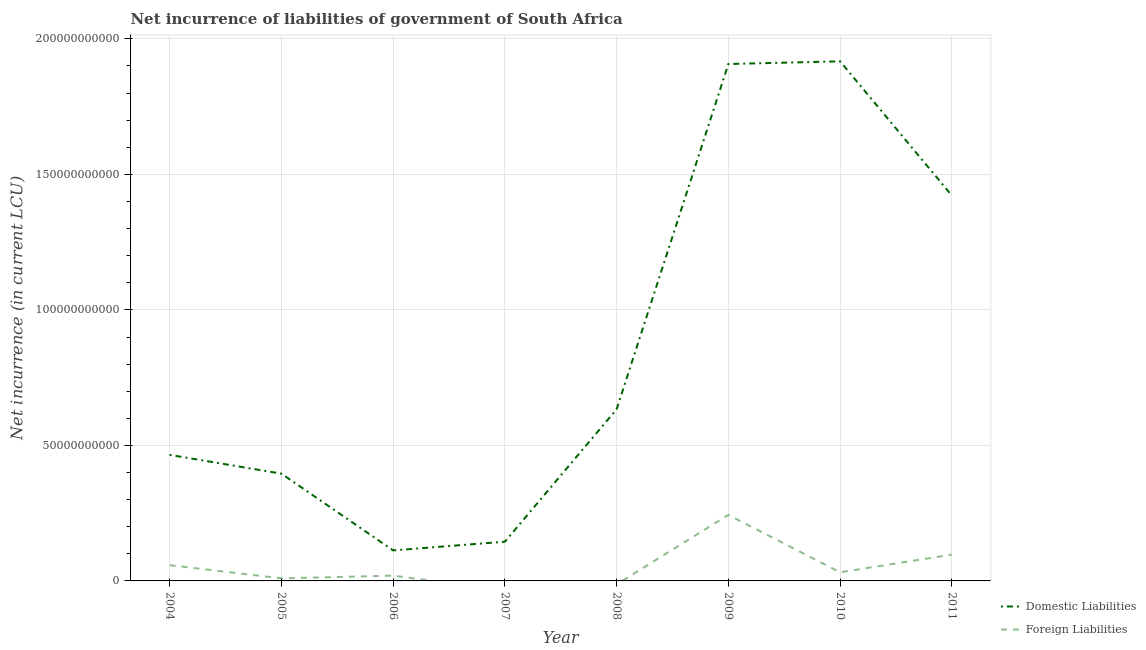How many different coloured lines are there?
Offer a terse response. 2. Is the number of lines equal to the number of legend labels?
Provide a succinct answer. No. What is the net incurrence of domestic liabilities in 2009?
Keep it short and to the point. 1.91e+11. Across all years, what is the maximum net incurrence of foreign liabilities?
Your answer should be very brief. 2.44e+1. What is the total net incurrence of domestic liabilities in the graph?
Offer a terse response. 7.00e+11. What is the difference between the net incurrence of domestic liabilities in 2004 and that in 2010?
Give a very brief answer. -1.45e+11. What is the difference between the net incurrence of foreign liabilities in 2006 and the net incurrence of domestic liabilities in 2008?
Your answer should be compact. -6.14e+1. What is the average net incurrence of domestic liabilities per year?
Give a very brief answer. 8.75e+1. In the year 2010, what is the difference between the net incurrence of foreign liabilities and net incurrence of domestic liabilities?
Your response must be concise. -1.89e+11. What is the ratio of the net incurrence of foreign liabilities in 2006 to that in 2010?
Ensure brevity in your answer.  0.61. Is the difference between the net incurrence of foreign liabilities in 2006 and 2010 greater than the difference between the net incurrence of domestic liabilities in 2006 and 2010?
Your answer should be very brief. Yes. What is the difference between the highest and the second highest net incurrence of foreign liabilities?
Provide a succinct answer. 1.46e+1. What is the difference between the highest and the lowest net incurrence of foreign liabilities?
Your answer should be compact. 2.44e+1. Is the sum of the net incurrence of foreign liabilities in 2010 and 2011 greater than the maximum net incurrence of domestic liabilities across all years?
Provide a short and direct response. No. How many years are there in the graph?
Make the answer very short. 8. Are the values on the major ticks of Y-axis written in scientific E-notation?
Provide a short and direct response. No. Does the graph contain any zero values?
Offer a terse response. Yes. What is the title of the graph?
Offer a terse response. Net incurrence of liabilities of government of South Africa. What is the label or title of the Y-axis?
Ensure brevity in your answer.  Net incurrence (in current LCU). What is the Net incurrence (in current LCU) of Domestic Liabilities in 2004?
Your answer should be compact. 4.65e+1. What is the Net incurrence (in current LCU) in Foreign Liabilities in 2004?
Give a very brief answer. 5.81e+09. What is the Net incurrence (in current LCU) in Domestic Liabilities in 2005?
Offer a very short reply. 3.96e+1. What is the Net incurrence (in current LCU) of Foreign Liabilities in 2005?
Provide a short and direct response. 9.50e+08. What is the Net incurrence (in current LCU) of Domestic Liabilities in 2006?
Offer a terse response. 1.13e+1. What is the Net incurrence (in current LCU) of Foreign Liabilities in 2006?
Your answer should be very brief. 1.94e+09. What is the Net incurrence (in current LCU) in Domestic Liabilities in 2007?
Offer a very short reply. 1.45e+1. What is the Net incurrence (in current LCU) in Domestic Liabilities in 2008?
Offer a very short reply. 6.33e+1. What is the Net incurrence (in current LCU) of Foreign Liabilities in 2008?
Provide a succinct answer. 0. What is the Net incurrence (in current LCU) of Domestic Liabilities in 2009?
Provide a short and direct response. 1.91e+11. What is the Net incurrence (in current LCU) of Foreign Liabilities in 2009?
Make the answer very short. 2.44e+1. What is the Net incurrence (in current LCU) of Domestic Liabilities in 2010?
Provide a short and direct response. 1.92e+11. What is the Net incurrence (in current LCU) in Foreign Liabilities in 2010?
Give a very brief answer. 3.18e+09. What is the Net incurrence (in current LCU) in Domestic Liabilities in 2011?
Provide a succinct answer. 1.42e+11. What is the Net incurrence (in current LCU) of Foreign Liabilities in 2011?
Provide a short and direct response. 9.71e+09. Across all years, what is the maximum Net incurrence (in current LCU) of Domestic Liabilities?
Offer a very short reply. 1.92e+11. Across all years, what is the maximum Net incurrence (in current LCU) in Foreign Liabilities?
Offer a very short reply. 2.44e+1. Across all years, what is the minimum Net incurrence (in current LCU) in Domestic Liabilities?
Ensure brevity in your answer.  1.13e+1. What is the total Net incurrence (in current LCU) in Domestic Liabilities in the graph?
Offer a terse response. 7.00e+11. What is the total Net incurrence (in current LCU) of Foreign Liabilities in the graph?
Provide a succinct answer. 4.59e+1. What is the difference between the Net incurrence (in current LCU) in Domestic Liabilities in 2004 and that in 2005?
Your answer should be compact. 6.92e+09. What is the difference between the Net incurrence (in current LCU) of Foreign Liabilities in 2004 and that in 2005?
Keep it short and to the point. 4.86e+09. What is the difference between the Net incurrence (in current LCU) in Domestic Liabilities in 2004 and that in 2006?
Give a very brief answer. 3.52e+1. What is the difference between the Net incurrence (in current LCU) of Foreign Liabilities in 2004 and that in 2006?
Give a very brief answer. 3.87e+09. What is the difference between the Net incurrence (in current LCU) of Domestic Liabilities in 2004 and that in 2007?
Offer a terse response. 3.20e+1. What is the difference between the Net incurrence (in current LCU) in Domestic Liabilities in 2004 and that in 2008?
Your response must be concise. -1.68e+1. What is the difference between the Net incurrence (in current LCU) in Domestic Liabilities in 2004 and that in 2009?
Keep it short and to the point. -1.44e+11. What is the difference between the Net incurrence (in current LCU) in Foreign Liabilities in 2004 and that in 2009?
Keep it short and to the point. -1.85e+1. What is the difference between the Net incurrence (in current LCU) of Domestic Liabilities in 2004 and that in 2010?
Offer a very short reply. -1.45e+11. What is the difference between the Net incurrence (in current LCU) of Foreign Liabilities in 2004 and that in 2010?
Make the answer very short. 2.63e+09. What is the difference between the Net incurrence (in current LCU) in Domestic Liabilities in 2004 and that in 2011?
Your answer should be compact. -9.57e+1. What is the difference between the Net incurrence (in current LCU) in Foreign Liabilities in 2004 and that in 2011?
Make the answer very short. -3.90e+09. What is the difference between the Net incurrence (in current LCU) in Domestic Liabilities in 2005 and that in 2006?
Your answer should be very brief. 2.83e+1. What is the difference between the Net incurrence (in current LCU) in Foreign Liabilities in 2005 and that in 2006?
Your answer should be compact. -9.93e+08. What is the difference between the Net incurrence (in current LCU) in Domestic Liabilities in 2005 and that in 2007?
Provide a succinct answer. 2.51e+1. What is the difference between the Net incurrence (in current LCU) in Domestic Liabilities in 2005 and that in 2008?
Your answer should be compact. -2.37e+1. What is the difference between the Net incurrence (in current LCU) in Domestic Liabilities in 2005 and that in 2009?
Keep it short and to the point. -1.51e+11. What is the difference between the Net incurrence (in current LCU) in Foreign Liabilities in 2005 and that in 2009?
Provide a succinct answer. -2.34e+1. What is the difference between the Net incurrence (in current LCU) in Domestic Liabilities in 2005 and that in 2010?
Give a very brief answer. -1.52e+11. What is the difference between the Net incurrence (in current LCU) of Foreign Liabilities in 2005 and that in 2010?
Make the answer very short. -2.23e+09. What is the difference between the Net incurrence (in current LCU) of Domestic Liabilities in 2005 and that in 2011?
Offer a very short reply. -1.03e+11. What is the difference between the Net incurrence (in current LCU) in Foreign Liabilities in 2005 and that in 2011?
Your response must be concise. -8.76e+09. What is the difference between the Net incurrence (in current LCU) of Domestic Liabilities in 2006 and that in 2007?
Your answer should be very brief. -3.21e+09. What is the difference between the Net incurrence (in current LCU) in Domestic Liabilities in 2006 and that in 2008?
Give a very brief answer. -5.21e+1. What is the difference between the Net incurrence (in current LCU) of Domestic Liabilities in 2006 and that in 2009?
Your response must be concise. -1.79e+11. What is the difference between the Net incurrence (in current LCU) in Foreign Liabilities in 2006 and that in 2009?
Give a very brief answer. -2.24e+1. What is the difference between the Net incurrence (in current LCU) in Domestic Liabilities in 2006 and that in 2010?
Your response must be concise. -1.80e+11. What is the difference between the Net incurrence (in current LCU) of Foreign Liabilities in 2006 and that in 2010?
Your answer should be very brief. -1.24e+09. What is the difference between the Net incurrence (in current LCU) of Domestic Liabilities in 2006 and that in 2011?
Ensure brevity in your answer.  -1.31e+11. What is the difference between the Net incurrence (in current LCU) of Foreign Liabilities in 2006 and that in 2011?
Provide a short and direct response. -7.77e+09. What is the difference between the Net incurrence (in current LCU) in Domestic Liabilities in 2007 and that in 2008?
Make the answer very short. -4.89e+1. What is the difference between the Net incurrence (in current LCU) in Domestic Liabilities in 2007 and that in 2009?
Offer a very short reply. -1.76e+11. What is the difference between the Net incurrence (in current LCU) in Domestic Liabilities in 2007 and that in 2010?
Provide a short and direct response. -1.77e+11. What is the difference between the Net incurrence (in current LCU) in Domestic Liabilities in 2007 and that in 2011?
Offer a terse response. -1.28e+11. What is the difference between the Net incurrence (in current LCU) in Domestic Liabilities in 2008 and that in 2009?
Your answer should be compact. -1.27e+11. What is the difference between the Net incurrence (in current LCU) in Domestic Liabilities in 2008 and that in 2010?
Your response must be concise. -1.28e+11. What is the difference between the Net incurrence (in current LCU) of Domestic Liabilities in 2008 and that in 2011?
Your response must be concise. -7.89e+1. What is the difference between the Net incurrence (in current LCU) in Domestic Liabilities in 2009 and that in 2010?
Offer a very short reply. -9.92e+08. What is the difference between the Net incurrence (in current LCU) in Foreign Liabilities in 2009 and that in 2010?
Offer a very short reply. 2.12e+1. What is the difference between the Net incurrence (in current LCU) of Domestic Liabilities in 2009 and that in 2011?
Give a very brief answer. 4.85e+1. What is the difference between the Net incurrence (in current LCU) in Foreign Liabilities in 2009 and that in 2011?
Your answer should be compact. 1.46e+1. What is the difference between the Net incurrence (in current LCU) of Domestic Liabilities in 2010 and that in 2011?
Your response must be concise. 4.95e+1. What is the difference between the Net incurrence (in current LCU) of Foreign Liabilities in 2010 and that in 2011?
Your answer should be compact. -6.53e+09. What is the difference between the Net incurrence (in current LCU) of Domestic Liabilities in 2004 and the Net incurrence (in current LCU) of Foreign Liabilities in 2005?
Ensure brevity in your answer.  4.56e+1. What is the difference between the Net incurrence (in current LCU) in Domestic Liabilities in 2004 and the Net incurrence (in current LCU) in Foreign Liabilities in 2006?
Give a very brief answer. 4.46e+1. What is the difference between the Net incurrence (in current LCU) in Domestic Liabilities in 2004 and the Net incurrence (in current LCU) in Foreign Liabilities in 2009?
Ensure brevity in your answer.  2.22e+1. What is the difference between the Net incurrence (in current LCU) of Domestic Liabilities in 2004 and the Net incurrence (in current LCU) of Foreign Liabilities in 2010?
Provide a succinct answer. 4.33e+1. What is the difference between the Net incurrence (in current LCU) in Domestic Liabilities in 2004 and the Net incurrence (in current LCU) in Foreign Liabilities in 2011?
Give a very brief answer. 3.68e+1. What is the difference between the Net incurrence (in current LCU) of Domestic Liabilities in 2005 and the Net incurrence (in current LCU) of Foreign Liabilities in 2006?
Ensure brevity in your answer.  3.76e+1. What is the difference between the Net incurrence (in current LCU) in Domestic Liabilities in 2005 and the Net incurrence (in current LCU) in Foreign Liabilities in 2009?
Provide a succinct answer. 1.52e+1. What is the difference between the Net incurrence (in current LCU) in Domestic Liabilities in 2005 and the Net incurrence (in current LCU) in Foreign Liabilities in 2010?
Your answer should be compact. 3.64e+1. What is the difference between the Net incurrence (in current LCU) of Domestic Liabilities in 2005 and the Net incurrence (in current LCU) of Foreign Liabilities in 2011?
Your answer should be compact. 2.99e+1. What is the difference between the Net incurrence (in current LCU) of Domestic Liabilities in 2006 and the Net incurrence (in current LCU) of Foreign Liabilities in 2009?
Offer a terse response. -1.31e+1. What is the difference between the Net incurrence (in current LCU) of Domestic Liabilities in 2006 and the Net incurrence (in current LCU) of Foreign Liabilities in 2010?
Provide a short and direct response. 8.08e+09. What is the difference between the Net incurrence (in current LCU) of Domestic Liabilities in 2006 and the Net incurrence (in current LCU) of Foreign Liabilities in 2011?
Provide a succinct answer. 1.55e+09. What is the difference between the Net incurrence (in current LCU) of Domestic Liabilities in 2007 and the Net incurrence (in current LCU) of Foreign Liabilities in 2009?
Provide a succinct answer. -9.88e+09. What is the difference between the Net incurrence (in current LCU) in Domestic Liabilities in 2007 and the Net incurrence (in current LCU) in Foreign Liabilities in 2010?
Provide a succinct answer. 1.13e+1. What is the difference between the Net incurrence (in current LCU) in Domestic Liabilities in 2007 and the Net incurrence (in current LCU) in Foreign Liabilities in 2011?
Keep it short and to the point. 4.76e+09. What is the difference between the Net incurrence (in current LCU) of Domestic Liabilities in 2008 and the Net incurrence (in current LCU) of Foreign Liabilities in 2009?
Your answer should be compact. 3.90e+1. What is the difference between the Net incurrence (in current LCU) in Domestic Liabilities in 2008 and the Net incurrence (in current LCU) in Foreign Liabilities in 2010?
Your answer should be compact. 6.01e+1. What is the difference between the Net incurrence (in current LCU) in Domestic Liabilities in 2008 and the Net incurrence (in current LCU) in Foreign Liabilities in 2011?
Make the answer very short. 5.36e+1. What is the difference between the Net incurrence (in current LCU) in Domestic Liabilities in 2009 and the Net incurrence (in current LCU) in Foreign Liabilities in 2010?
Ensure brevity in your answer.  1.88e+11. What is the difference between the Net incurrence (in current LCU) in Domestic Liabilities in 2009 and the Net incurrence (in current LCU) in Foreign Liabilities in 2011?
Offer a terse response. 1.81e+11. What is the difference between the Net incurrence (in current LCU) of Domestic Liabilities in 2010 and the Net incurrence (in current LCU) of Foreign Liabilities in 2011?
Keep it short and to the point. 1.82e+11. What is the average Net incurrence (in current LCU) in Domestic Liabilities per year?
Offer a very short reply. 8.75e+1. What is the average Net incurrence (in current LCU) of Foreign Liabilities per year?
Make the answer very short. 5.74e+09. In the year 2004, what is the difference between the Net incurrence (in current LCU) in Domestic Liabilities and Net incurrence (in current LCU) in Foreign Liabilities?
Ensure brevity in your answer.  4.07e+1. In the year 2005, what is the difference between the Net incurrence (in current LCU) of Domestic Liabilities and Net incurrence (in current LCU) of Foreign Liabilities?
Provide a succinct answer. 3.86e+1. In the year 2006, what is the difference between the Net incurrence (in current LCU) in Domestic Liabilities and Net incurrence (in current LCU) in Foreign Liabilities?
Provide a succinct answer. 9.32e+09. In the year 2009, what is the difference between the Net incurrence (in current LCU) in Domestic Liabilities and Net incurrence (in current LCU) in Foreign Liabilities?
Your answer should be very brief. 1.66e+11. In the year 2010, what is the difference between the Net incurrence (in current LCU) in Domestic Liabilities and Net incurrence (in current LCU) in Foreign Liabilities?
Keep it short and to the point. 1.89e+11. In the year 2011, what is the difference between the Net incurrence (in current LCU) in Domestic Liabilities and Net incurrence (in current LCU) in Foreign Liabilities?
Offer a terse response. 1.32e+11. What is the ratio of the Net incurrence (in current LCU) in Domestic Liabilities in 2004 to that in 2005?
Your response must be concise. 1.17. What is the ratio of the Net incurrence (in current LCU) of Foreign Liabilities in 2004 to that in 2005?
Provide a succinct answer. 6.11. What is the ratio of the Net incurrence (in current LCU) in Domestic Liabilities in 2004 to that in 2006?
Make the answer very short. 4.13. What is the ratio of the Net incurrence (in current LCU) in Foreign Liabilities in 2004 to that in 2006?
Ensure brevity in your answer.  2.99. What is the ratio of the Net incurrence (in current LCU) of Domestic Liabilities in 2004 to that in 2007?
Provide a succinct answer. 3.21. What is the ratio of the Net incurrence (in current LCU) in Domestic Liabilities in 2004 to that in 2008?
Provide a short and direct response. 0.73. What is the ratio of the Net incurrence (in current LCU) in Domestic Liabilities in 2004 to that in 2009?
Your answer should be very brief. 0.24. What is the ratio of the Net incurrence (in current LCU) of Foreign Liabilities in 2004 to that in 2009?
Make the answer very short. 0.24. What is the ratio of the Net incurrence (in current LCU) of Domestic Liabilities in 2004 to that in 2010?
Ensure brevity in your answer.  0.24. What is the ratio of the Net incurrence (in current LCU) of Foreign Liabilities in 2004 to that in 2010?
Make the answer very short. 1.83. What is the ratio of the Net incurrence (in current LCU) of Domestic Liabilities in 2004 to that in 2011?
Offer a very short reply. 0.33. What is the ratio of the Net incurrence (in current LCU) of Foreign Liabilities in 2004 to that in 2011?
Your response must be concise. 0.6. What is the ratio of the Net incurrence (in current LCU) in Domestic Liabilities in 2005 to that in 2006?
Ensure brevity in your answer.  3.52. What is the ratio of the Net incurrence (in current LCU) in Foreign Liabilities in 2005 to that in 2006?
Your answer should be very brief. 0.49. What is the ratio of the Net incurrence (in current LCU) of Domestic Liabilities in 2005 to that in 2007?
Your answer should be compact. 2.73. What is the ratio of the Net incurrence (in current LCU) of Domestic Liabilities in 2005 to that in 2008?
Offer a terse response. 0.63. What is the ratio of the Net incurrence (in current LCU) in Domestic Liabilities in 2005 to that in 2009?
Provide a short and direct response. 0.21. What is the ratio of the Net incurrence (in current LCU) of Foreign Liabilities in 2005 to that in 2009?
Provide a succinct answer. 0.04. What is the ratio of the Net incurrence (in current LCU) in Domestic Liabilities in 2005 to that in 2010?
Keep it short and to the point. 0.21. What is the ratio of the Net incurrence (in current LCU) of Foreign Liabilities in 2005 to that in 2010?
Offer a terse response. 0.3. What is the ratio of the Net incurrence (in current LCU) of Domestic Liabilities in 2005 to that in 2011?
Give a very brief answer. 0.28. What is the ratio of the Net incurrence (in current LCU) in Foreign Liabilities in 2005 to that in 2011?
Provide a short and direct response. 0.1. What is the ratio of the Net incurrence (in current LCU) of Domestic Liabilities in 2006 to that in 2007?
Keep it short and to the point. 0.78. What is the ratio of the Net incurrence (in current LCU) in Domestic Liabilities in 2006 to that in 2008?
Offer a terse response. 0.18. What is the ratio of the Net incurrence (in current LCU) of Domestic Liabilities in 2006 to that in 2009?
Your answer should be very brief. 0.06. What is the ratio of the Net incurrence (in current LCU) of Foreign Liabilities in 2006 to that in 2009?
Ensure brevity in your answer.  0.08. What is the ratio of the Net incurrence (in current LCU) in Domestic Liabilities in 2006 to that in 2010?
Keep it short and to the point. 0.06. What is the ratio of the Net incurrence (in current LCU) in Foreign Liabilities in 2006 to that in 2010?
Your answer should be very brief. 0.61. What is the ratio of the Net incurrence (in current LCU) in Domestic Liabilities in 2006 to that in 2011?
Make the answer very short. 0.08. What is the ratio of the Net incurrence (in current LCU) in Foreign Liabilities in 2006 to that in 2011?
Offer a terse response. 0.2. What is the ratio of the Net incurrence (in current LCU) in Domestic Liabilities in 2007 to that in 2008?
Offer a terse response. 0.23. What is the ratio of the Net incurrence (in current LCU) of Domestic Liabilities in 2007 to that in 2009?
Provide a succinct answer. 0.08. What is the ratio of the Net incurrence (in current LCU) in Domestic Liabilities in 2007 to that in 2010?
Offer a terse response. 0.08. What is the ratio of the Net incurrence (in current LCU) in Domestic Liabilities in 2007 to that in 2011?
Your answer should be very brief. 0.1. What is the ratio of the Net incurrence (in current LCU) of Domestic Liabilities in 2008 to that in 2009?
Your response must be concise. 0.33. What is the ratio of the Net incurrence (in current LCU) in Domestic Liabilities in 2008 to that in 2010?
Give a very brief answer. 0.33. What is the ratio of the Net incurrence (in current LCU) in Domestic Liabilities in 2008 to that in 2011?
Offer a terse response. 0.45. What is the ratio of the Net incurrence (in current LCU) in Foreign Liabilities in 2009 to that in 2010?
Give a very brief answer. 7.65. What is the ratio of the Net incurrence (in current LCU) in Domestic Liabilities in 2009 to that in 2011?
Provide a succinct answer. 1.34. What is the ratio of the Net incurrence (in current LCU) of Foreign Liabilities in 2009 to that in 2011?
Offer a terse response. 2.51. What is the ratio of the Net incurrence (in current LCU) of Domestic Liabilities in 2010 to that in 2011?
Offer a very short reply. 1.35. What is the ratio of the Net incurrence (in current LCU) in Foreign Liabilities in 2010 to that in 2011?
Your answer should be very brief. 0.33. What is the difference between the highest and the second highest Net incurrence (in current LCU) in Domestic Liabilities?
Provide a succinct answer. 9.92e+08. What is the difference between the highest and the second highest Net incurrence (in current LCU) in Foreign Liabilities?
Ensure brevity in your answer.  1.46e+1. What is the difference between the highest and the lowest Net incurrence (in current LCU) in Domestic Liabilities?
Your response must be concise. 1.80e+11. What is the difference between the highest and the lowest Net incurrence (in current LCU) in Foreign Liabilities?
Your answer should be very brief. 2.44e+1. 